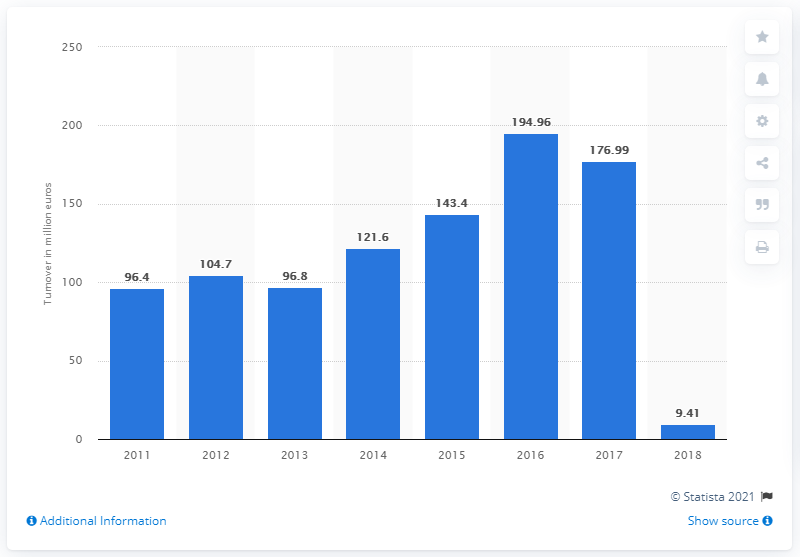List a handful of essential elements in this visual. In 2016, Bulgari's annual turnover was 194.96 million euros. Bulgari's turnover in 2018 was 9.41 billion euros. 